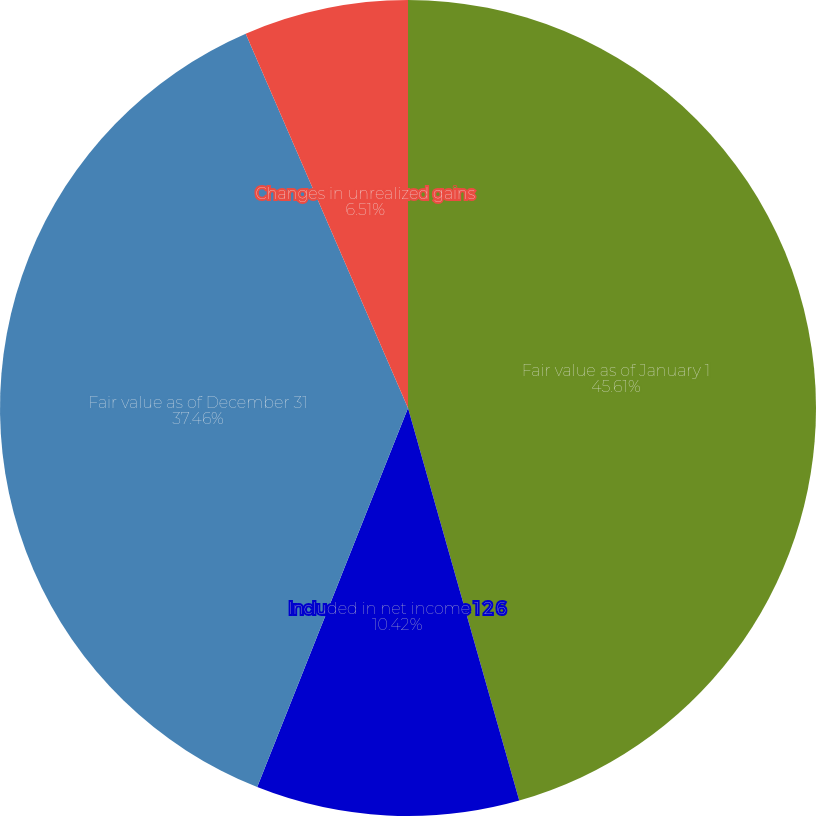Convert chart. <chart><loc_0><loc_0><loc_500><loc_500><pie_chart><fcel>Fair value as of January 1<fcel>Included in net income 1 2 6<fcel>Fair value as of December 31<fcel>Changes in unrealized gains<nl><fcel>45.6%<fcel>10.42%<fcel>37.46%<fcel>6.51%<nl></chart> 